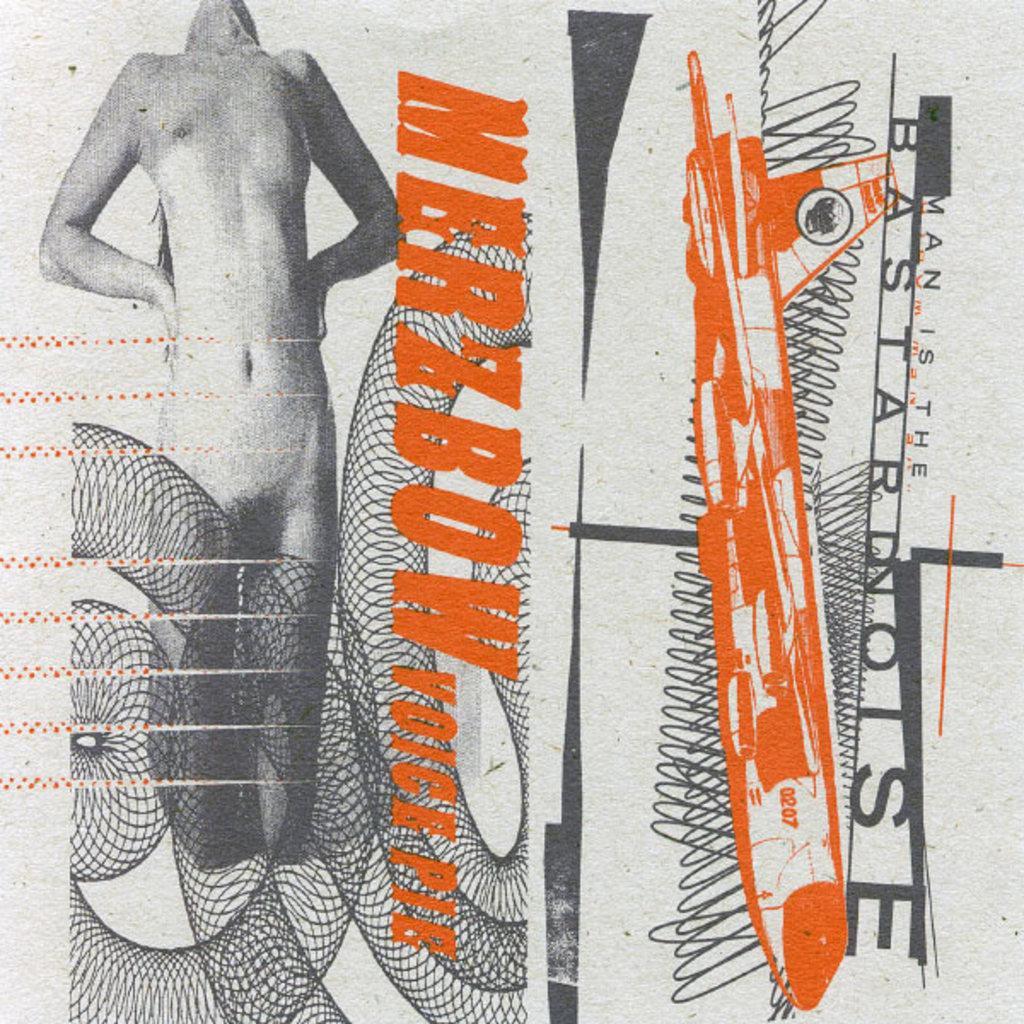Please provide a concise description of this image. In this picture I can see there is a woman into left and there is an aircraft at right side, there is something written on the image. 